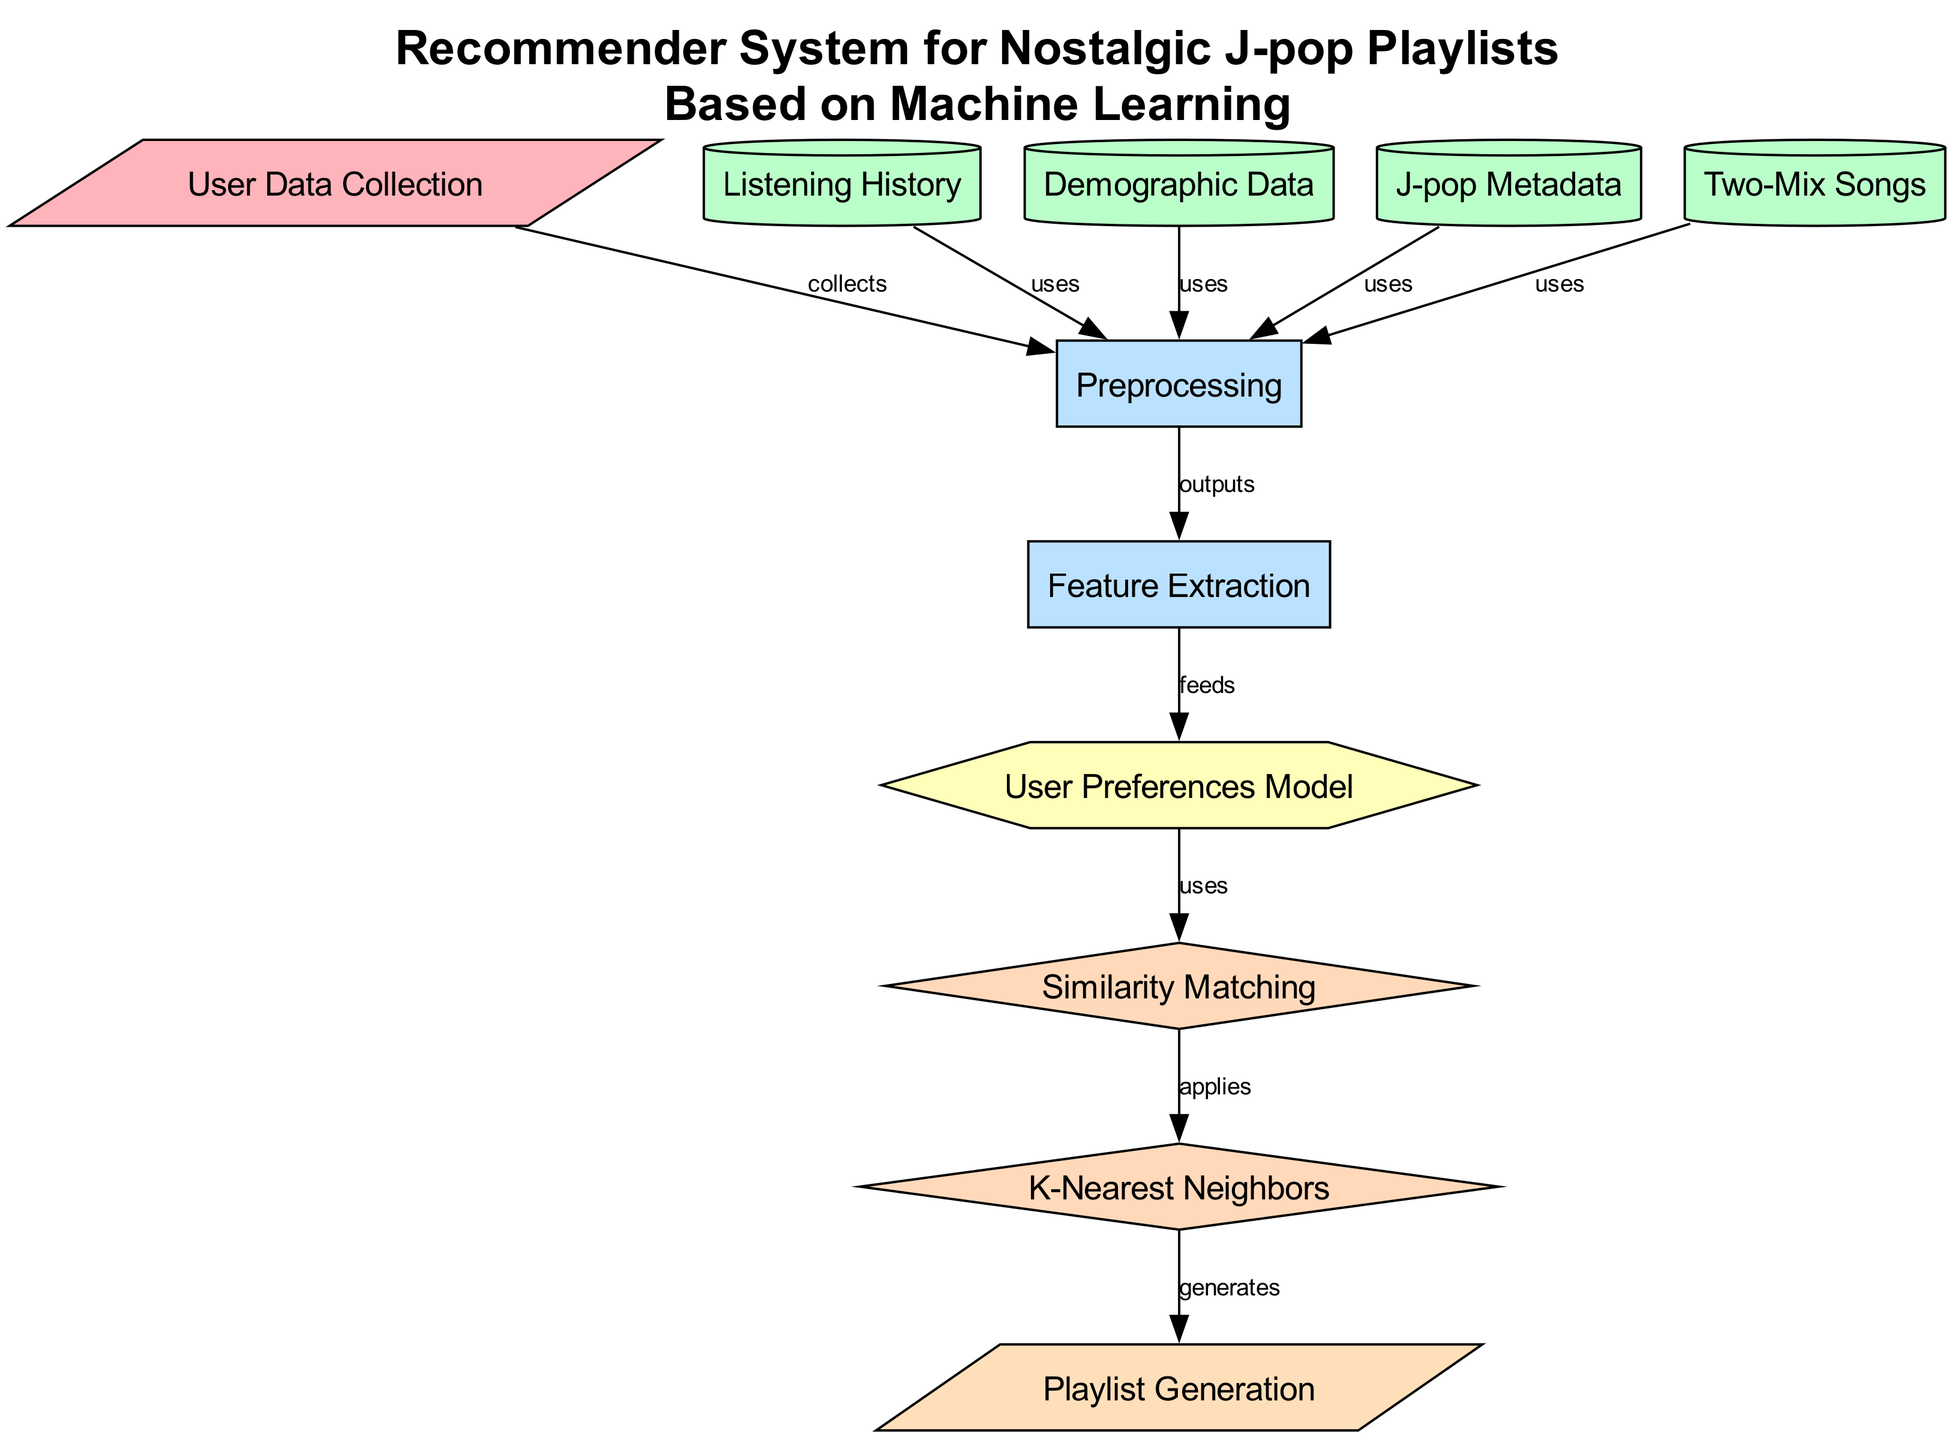What is the first step in the diagram? The first step in the diagram is "User Data Collection," which is depicted as the initial input node. This node is the starting point for collecting information relevant to the user's preferences in J-pop music.
Answer: User Data Collection How many data nodes are present in this diagram? The diagram includes four data nodes: Listening History, Demographic Data, J-pop Metadata, and Two-Mix Songs. Counting these nodes gives a total of four.
Answer: 4 Which algorithm is used after the User Preferences Model? The algorithm used after the User Preferences Model is "Similarity Matching." This follows directly in the flow of information from the model to the algorithm stage.
Answer: Similarity Matching What type of node is "Playlist Generation"? "Playlist Generation" is classified as an output node, which is indicated by its parallelogram shape and its position at the end of the flow, representing the end result of the process.
Answer: output In what step does Feature Extraction occur? Feature Extraction occurs after Preprocessing, as indicated by the flow that connects these two process nodes. The output of Preprocessing feeds into Feature Extraction, making it the next logical step.
Answer: 7 How is the K-Nearest Neighbors algorithm related to the Playlist Generation? The K-Nearest Neighbors algorithm applies its logic to generate Playlist Generation outputs, showing a direct link between the two nodes. K-Nearest Neighbors processes the results from Similarity Matching to finally generate recommended playlists.
Answer: generates What type of data is "J-pop Metadata"? "J-pop Metadata" is classified as a data node. It contributes to the overall information needed for processing user preferences and is represented in a way that signifies it holds data useful for the analysis.
Answer: data Which node directly uses the Listening History? The Preprocessing node directly uses the Listening History as one of its inputs, indicating that the listening history data is essential in the preprocessing phase.
Answer: Preprocessing How many total edges connect the nodes in the diagram? There are ten edges that connect the nodes in the diagram, indicating relationships and data flow between the various components of the recommender system.
Answer: 10 